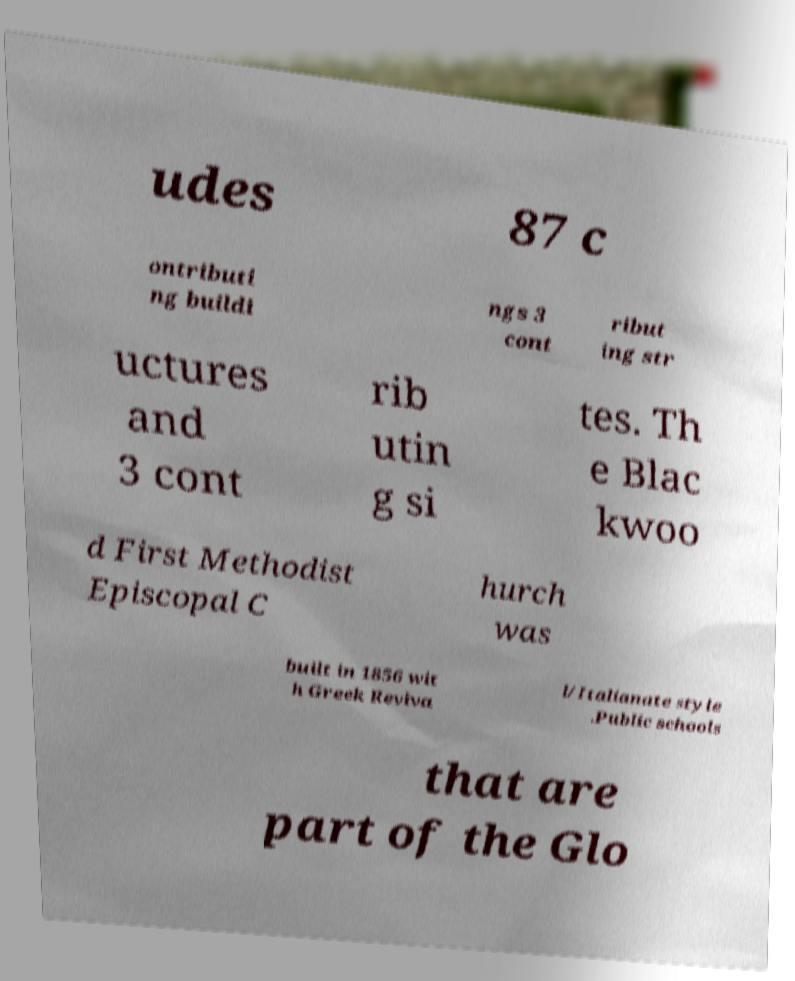Could you extract and type out the text from this image? udes 87 c ontributi ng buildi ngs 3 cont ribut ing str uctures and 3 cont rib utin g si tes. Th e Blac kwoo d First Methodist Episcopal C hurch was built in 1856 wit h Greek Reviva l/Italianate style .Public schools that are part of the Glo 